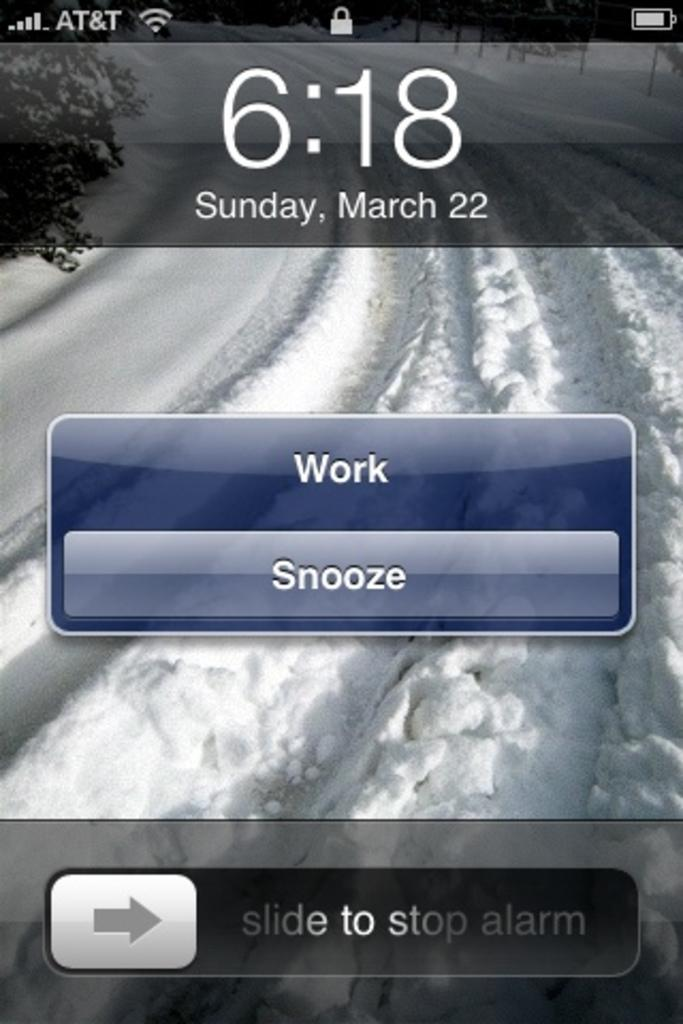Provide a one-sentence caption for the provided image. An alarm with a work and a snooze button. 